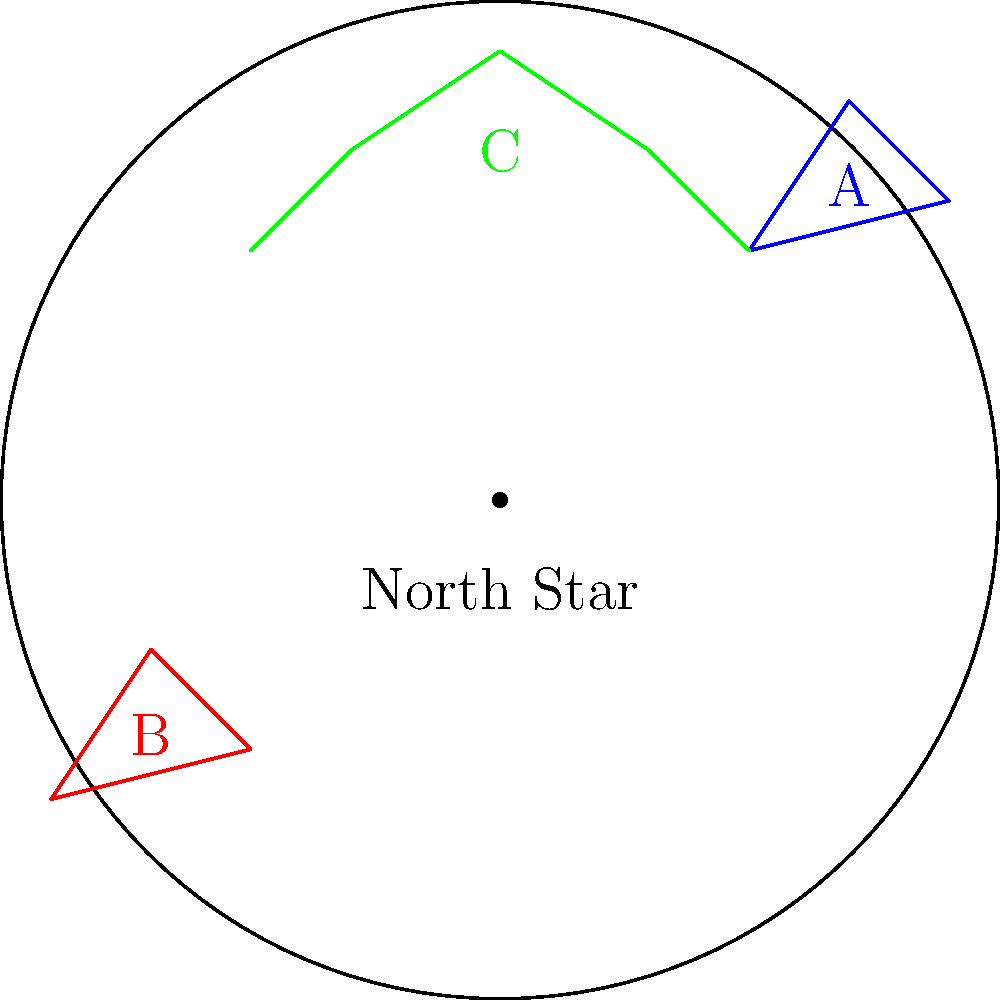You've discovered an ancient star chart in your collection. The chart shows three distinct constellations (labeled A, B, and C) arranged around a central point marked as the North Star. Based on their positions relative to the North Star, which constellation is most likely to represent Ursa Major (The Big Dipper)? To determine which constellation is most likely to represent Ursa Major (The Big Dipper), we need to consider its position relative to the North Star (Polaris). Let's analyze each constellation:

1. The North Star (Polaris) is at the center of the chart, representing the celestial north pole.

2. Ursa Major is known to be circumpolar in the northern hemisphere, meaning it's always visible and rotates around the North Star.

3. The Big Dipper, part of Ursa Major, is often used to locate the North Star. It's typically found above or to the side of the North Star, never below it.

4. Analyzing the constellations:
   a) Constellation A (blue): Located in the upper right quadrant, above the North Star.
   b) Constellation B (red): Located in the lower left quadrant, below the North Star.
   c) Constellation C (green): Spans across the top of the chart, above the North Star.

5. Given its position above the North Star and its distinctive shape resembling a dipper or ladle, Constellation C (green) is most likely to represent Ursa Major.

6. Constellations A and B are less likely candidates due to their positions and shapes.
Answer: Constellation C (green) 